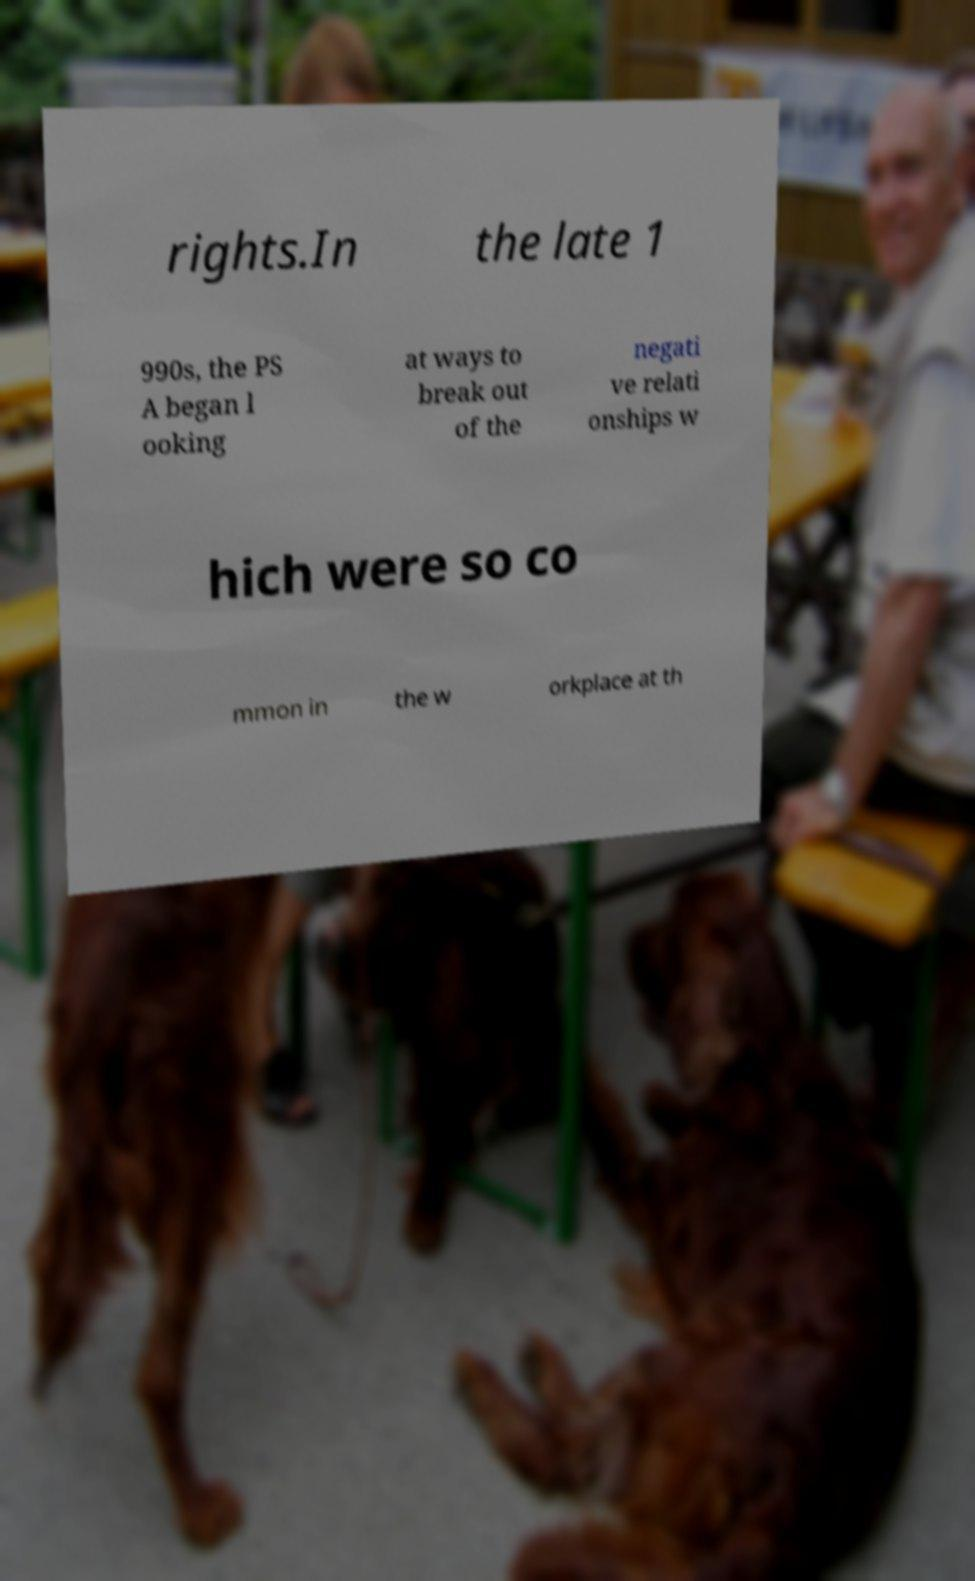Could you assist in decoding the text presented in this image and type it out clearly? rights.In the late 1 990s, the PS A began l ooking at ways to break out of the negati ve relati onships w hich were so co mmon in the w orkplace at th 